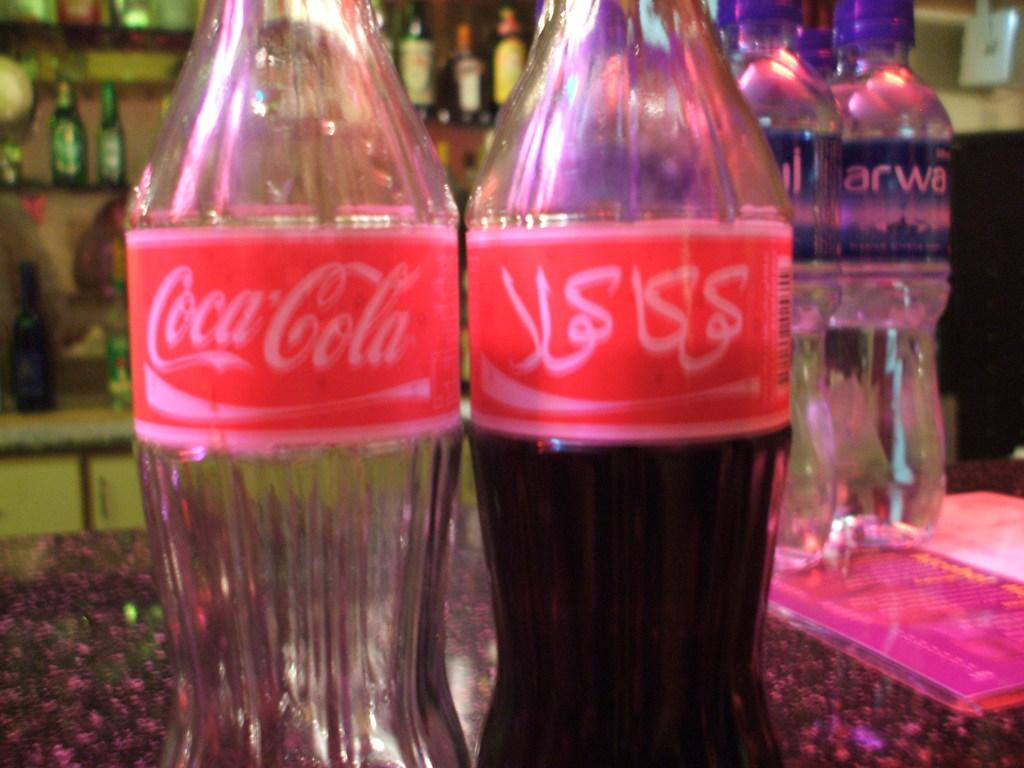What objects are present in the image? There are bottles in the image. How are the bottles arranged in the image? Some bottles are behind other bottles. What type of curtain can be seen hanging behind the bottles in the image? There is no curtain present in the image; it only features bottles arranged in a certain way. 